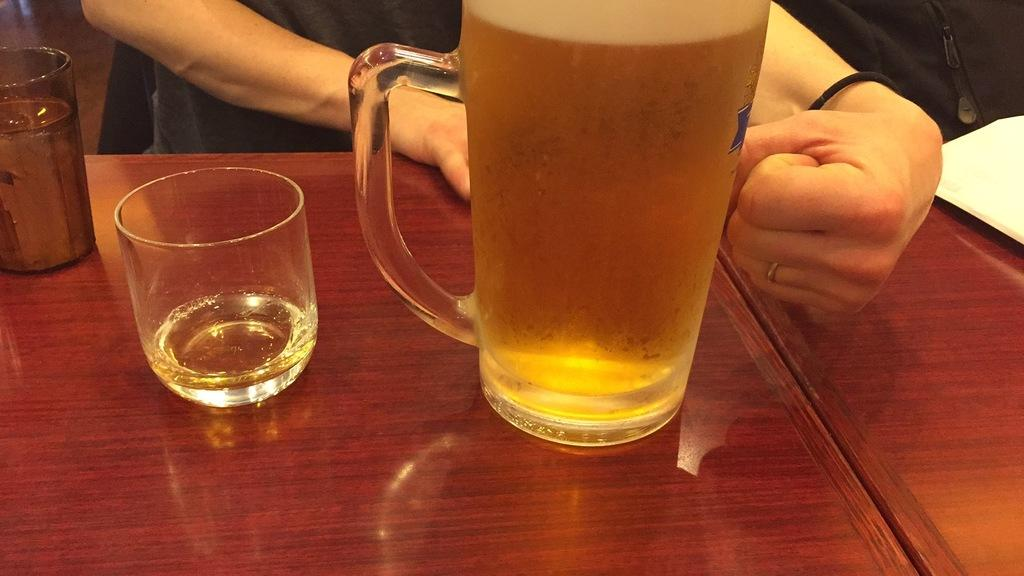What type of furniture is present in the image? There are tables in the image. What objects can be seen on the tables? There are glasses, a jar, and a book on the tables. How many people are visible behind the tables? There are two people behind the tables. What type of ship can be seen sailing in the background of the image? There is no ship visible in the image; it only features tables, objects on the tables, and people behind the tables. Can you tell me how much quartz is present on the tables? There is no quartz present on the tables in the image. 